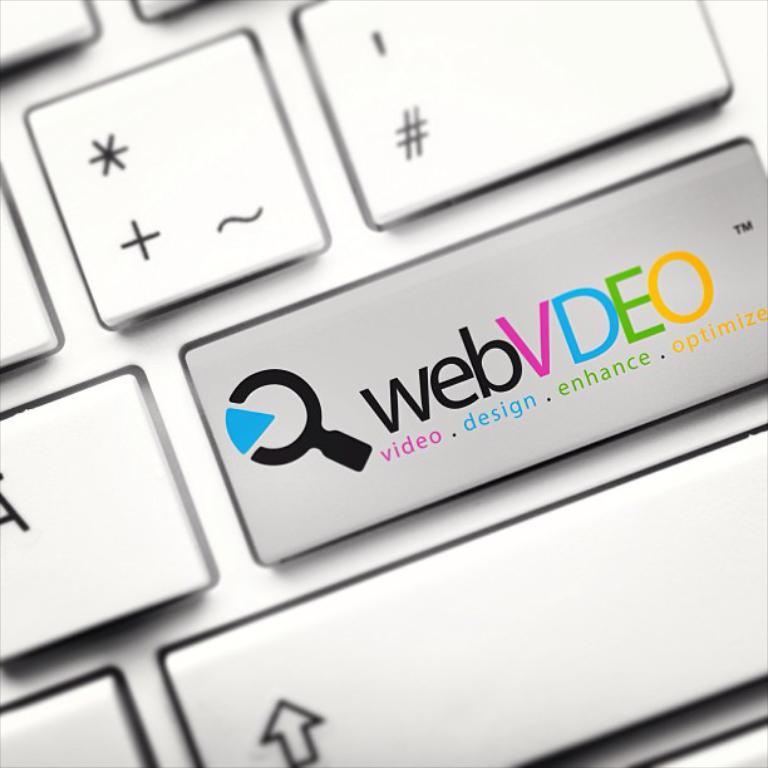What does the v stand for?
Your answer should be compact. Video. What does the e stand for?
Offer a very short reply. Enhance. 